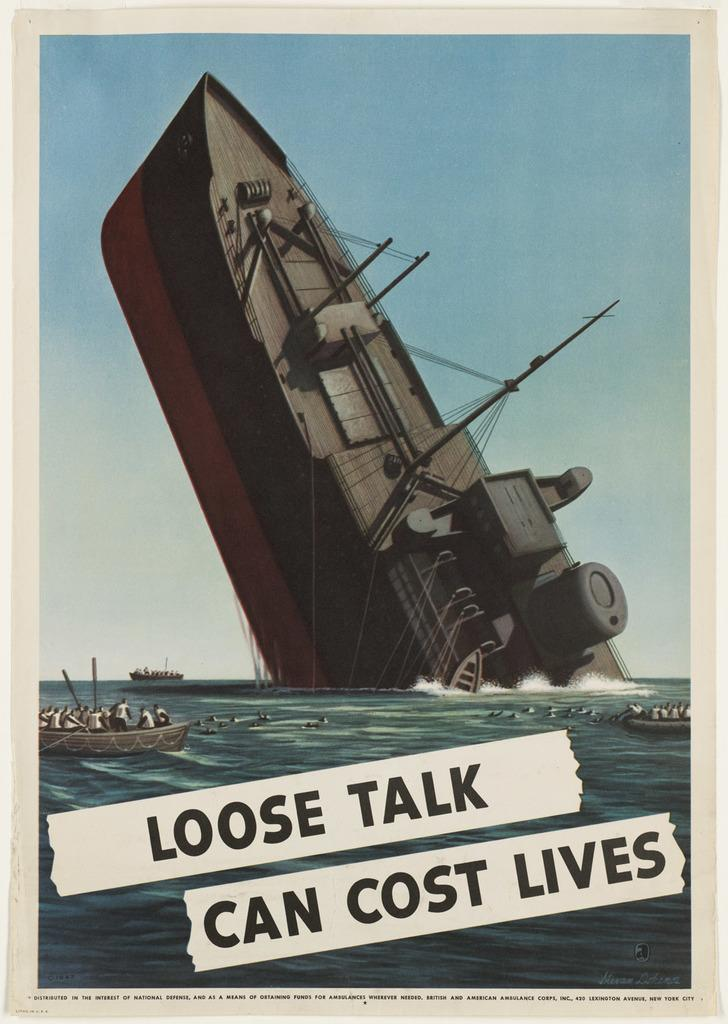What type of vehicle is in the image? There is a ship in the image. Are there any other similar vehicles in the image? Yes, there are boats in the image. Where are the ship and boats located? The ship and boats are on the surface of water. What else can be seen in the image besides the ship and boats? There is text written on a poster. How many snakes are slithering on the ship in the image? There are no snakes present in the image; it features a ship and boats on the water. 